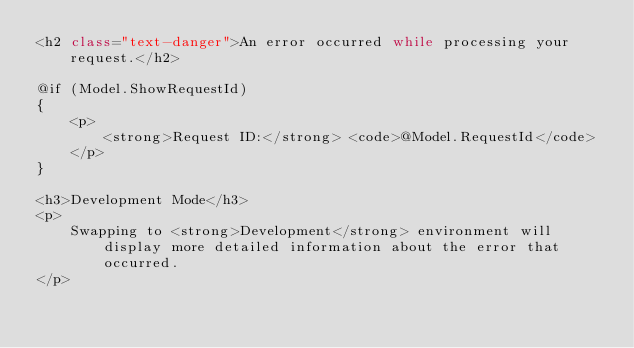<code> <loc_0><loc_0><loc_500><loc_500><_C#_><h2 class="text-danger">An error occurred while processing your request.</h2>

@if (Model.ShowRequestId)
{
    <p>
        <strong>Request ID:</strong> <code>@Model.RequestId</code>
    </p>
}

<h3>Development Mode</h3>
<p>
    Swapping to <strong>Development</strong> environment will display more detailed information about the error that occurred.
</p>
</code> 